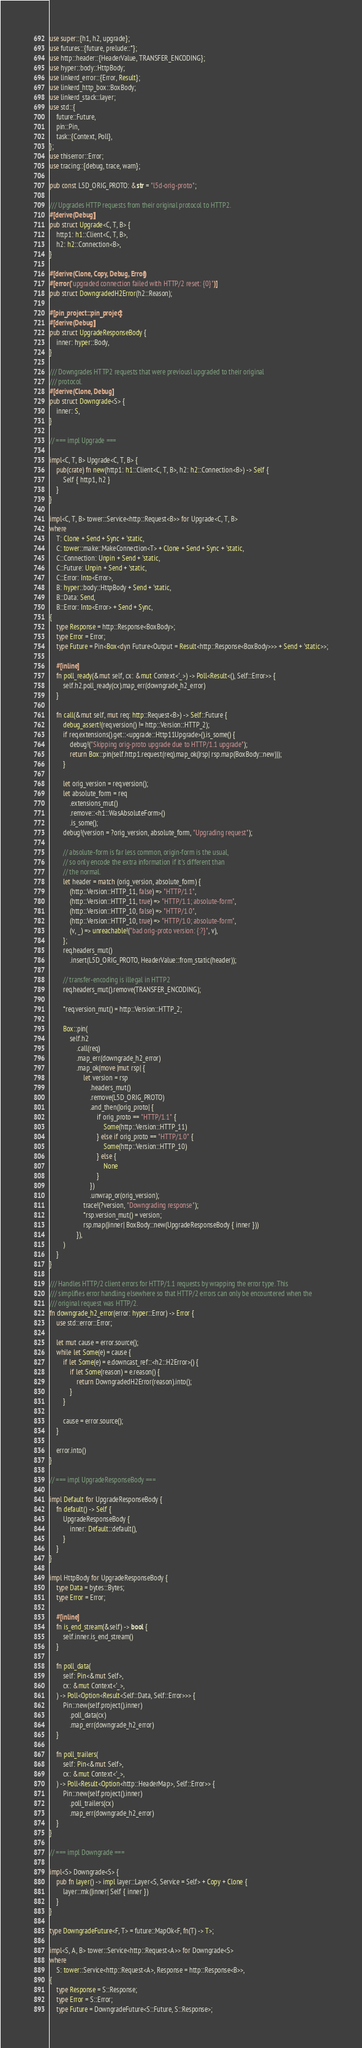<code> <loc_0><loc_0><loc_500><loc_500><_Rust_>use super::{h1, h2, upgrade};
use futures::{future, prelude::*};
use http::header::{HeaderValue, TRANSFER_ENCODING};
use hyper::body::HttpBody;
use linkerd_error::{Error, Result};
use linkerd_http_box::BoxBody;
use linkerd_stack::layer;
use std::{
    future::Future,
    pin::Pin,
    task::{Context, Poll},
};
use thiserror::Error;
use tracing::{debug, trace, warn};

pub const L5D_ORIG_PROTO: &str = "l5d-orig-proto";

/// Upgrades HTTP requests from their original protocol to HTTP2.
#[derive(Debug)]
pub struct Upgrade<C, T, B> {
    http1: h1::Client<C, T, B>,
    h2: h2::Connection<B>,
}

#[derive(Clone, Copy, Debug, Error)]
#[error("upgraded connection failed with HTTP/2 reset: {0}")]
pub struct DowngradedH2Error(h2::Reason);

#[pin_project::pin_project]
#[derive(Debug)]
pub struct UpgradeResponseBody {
    inner: hyper::Body,
}

/// Downgrades HTTP2 requests that were previousl upgraded to their original
/// protocol.
#[derive(Clone, Debug)]
pub struct Downgrade<S> {
    inner: S,
}

// === impl Upgrade ===

impl<C, T, B> Upgrade<C, T, B> {
    pub(crate) fn new(http1: h1::Client<C, T, B>, h2: h2::Connection<B>) -> Self {
        Self { http1, h2 }
    }
}

impl<C, T, B> tower::Service<http::Request<B>> for Upgrade<C, T, B>
where
    T: Clone + Send + Sync + 'static,
    C: tower::make::MakeConnection<T> + Clone + Send + Sync + 'static,
    C::Connection: Unpin + Send + 'static,
    C::Future: Unpin + Send + 'static,
    C::Error: Into<Error>,
    B: hyper::body::HttpBody + Send + 'static,
    B::Data: Send,
    B::Error: Into<Error> + Send + Sync,
{
    type Response = http::Response<BoxBody>;
    type Error = Error;
    type Future = Pin<Box<dyn Future<Output = Result<http::Response<BoxBody>>> + Send + 'static>>;

    #[inline]
    fn poll_ready(&mut self, cx: &mut Context<'_>) -> Poll<Result<(), Self::Error>> {
        self.h2.poll_ready(cx).map_err(downgrade_h2_error)
    }

    fn call(&mut self, mut req: http::Request<B>) -> Self::Future {
        debug_assert!(req.version() != http::Version::HTTP_2);
        if req.extensions().get::<upgrade::Http11Upgrade>().is_some() {
            debug!("Skipping orig-proto upgrade due to HTTP/1.1 upgrade");
            return Box::pin(self.http1.request(req).map_ok(|rsp| rsp.map(BoxBody::new)));
        }

        let orig_version = req.version();
        let absolute_form = req
            .extensions_mut()
            .remove::<h1::WasAbsoluteForm>()
            .is_some();
        debug!(version = ?orig_version, absolute_form, "Upgrading request");

        // absolute-form is far less common, origin-form is the usual,
        // so only encode the extra information if it's different than
        // the normal.
        let header = match (orig_version, absolute_form) {
            (http::Version::HTTP_11, false) => "HTTP/1.1",
            (http::Version::HTTP_11, true) => "HTTP/1.1; absolute-form",
            (http::Version::HTTP_10, false) => "HTTP/1.0",
            (http::Version::HTTP_10, true) => "HTTP/1.0; absolute-form",
            (v, _) => unreachable!("bad orig-proto version: {:?}", v),
        };
        req.headers_mut()
            .insert(L5D_ORIG_PROTO, HeaderValue::from_static(header));

        // transfer-encoding is illegal in HTTP2
        req.headers_mut().remove(TRANSFER_ENCODING);

        *req.version_mut() = http::Version::HTTP_2;

        Box::pin(
            self.h2
                .call(req)
                .map_err(downgrade_h2_error)
                .map_ok(move |mut rsp| {
                    let version = rsp
                        .headers_mut()
                        .remove(L5D_ORIG_PROTO)
                        .and_then(|orig_proto| {
                            if orig_proto == "HTTP/1.1" {
                                Some(http::Version::HTTP_11)
                            } else if orig_proto == "HTTP/1.0" {
                                Some(http::Version::HTTP_10)
                            } else {
                                None
                            }
                        })
                        .unwrap_or(orig_version);
                    trace!(?version, "Downgrading response");
                    *rsp.version_mut() = version;
                    rsp.map(|inner| BoxBody::new(UpgradeResponseBody { inner }))
                }),
        )
    }
}

/// Handles HTTP/2 client errors for HTTP/1.1 requests by wrapping the error type. This
/// simplifies error handling elsewhere so that HTTP/2 errors can only be encountered when the
/// original request was HTTP/2.
fn downgrade_h2_error(error: hyper::Error) -> Error {
    use std::error::Error;

    let mut cause = error.source();
    while let Some(e) = cause {
        if let Some(e) = e.downcast_ref::<h2::H2Error>() {
            if let Some(reason) = e.reason() {
                return DowngradedH2Error(reason).into();
            }
        }

        cause = error.source();
    }

    error.into()
}

// === impl UpgradeResponseBody ===

impl Default for UpgradeResponseBody {
    fn default() -> Self {
        UpgradeResponseBody {
            inner: Default::default(),
        }
    }
}

impl HttpBody for UpgradeResponseBody {
    type Data = bytes::Bytes;
    type Error = Error;

    #[inline]
    fn is_end_stream(&self) -> bool {
        self.inner.is_end_stream()
    }

    fn poll_data(
        self: Pin<&mut Self>,
        cx: &mut Context<'_>,
    ) -> Poll<Option<Result<Self::Data, Self::Error>>> {
        Pin::new(self.project().inner)
            .poll_data(cx)
            .map_err(downgrade_h2_error)
    }

    fn poll_trailers(
        self: Pin<&mut Self>,
        cx: &mut Context<'_>,
    ) -> Poll<Result<Option<http::HeaderMap>, Self::Error>> {
        Pin::new(self.project().inner)
            .poll_trailers(cx)
            .map_err(downgrade_h2_error)
    }
}

// === impl Downgrade ===

impl<S> Downgrade<S> {
    pub fn layer() -> impl layer::Layer<S, Service = Self> + Copy + Clone {
        layer::mk(|inner| Self { inner })
    }
}

type DowngradeFuture<F, T> = future::MapOk<F, fn(T) -> T>;

impl<S, A, B> tower::Service<http::Request<A>> for Downgrade<S>
where
    S: tower::Service<http::Request<A>, Response = http::Response<B>>,
{
    type Response = S::Response;
    type Error = S::Error;
    type Future = DowngradeFuture<S::Future, S::Response>;
</code> 